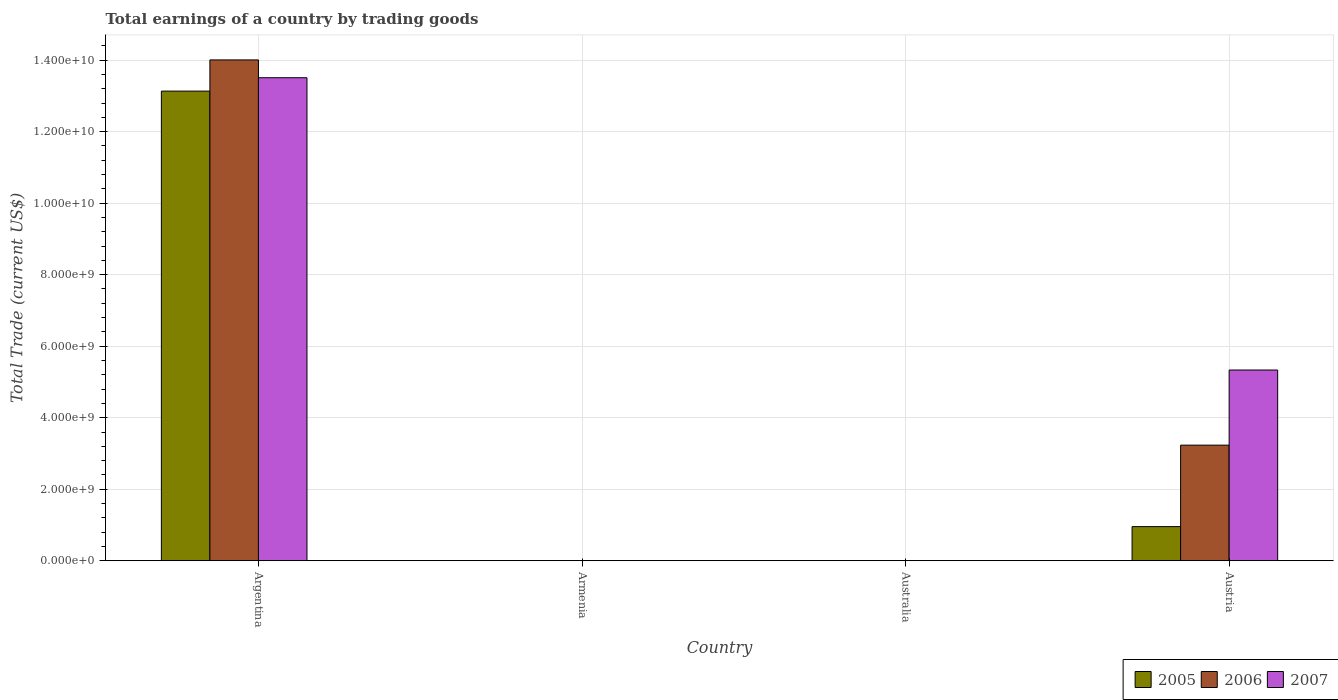How many different coloured bars are there?
Your answer should be compact. 3. Are the number of bars per tick equal to the number of legend labels?
Your answer should be compact. No. How many bars are there on the 2nd tick from the left?
Offer a very short reply. 0. How many bars are there on the 2nd tick from the right?
Your answer should be compact. 0. In how many cases, is the number of bars for a given country not equal to the number of legend labels?
Make the answer very short. 2. What is the total earnings in 2006 in Australia?
Your answer should be compact. 0. Across all countries, what is the maximum total earnings in 2006?
Your response must be concise. 1.40e+1. What is the total total earnings in 2006 in the graph?
Ensure brevity in your answer.  1.72e+1. What is the difference between the total earnings in 2005 in Argentina and that in Austria?
Make the answer very short. 1.22e+1. What is the average total earnings in 2005 per country?
Provide a succinct answer. 3.52e+09. What is the difference between the total earnings of/in 2007 and total earnings of/in 2005 in Argentina?
Offer a very short reply. 3.74e+08. What is the ratio of the total earnings in 2007 in Argentina to that in Austria?
Keep it short and to the point. 2.53. What is the difference between the highest and the lowest total earnings in 2006?
Give a very brief answer. 1.40e+1. In how many countries, is the total earnings in 2005 greater than the average total earnings in 2005 taken over all countries?
Ensure brevity in your answer.  1. How many bars are there?
Your response must be concise. 6. Are all the bars in the graph horizontal?
Your answer should be very brief. No. How many countries are there in the graph?
Offer a terse response. 4. Are the values on the major ticks of Y-axis written in scientific E-notation?
Your response must be concise. Yes. Does the graph contain any zero values?
Ensure brevity in your answer.  Yes. Does the graph contain grids?
Provide a succinct answer. Yes. Where does the legend appear in the graph?
Give a very brief answer. Bottom right. How many legend labels are there?
Ensure brevity in your answer.  3. How are the legend labels stacked?
Ensure brevity in your answer.  Horizontal. What is the title of the graph?
Ensure brevity in your answer.  Total earnings of a country by trading goods. What is the label or title of the X-axis?
Give a very brief answer. Country. What is the label or title of the Y-axis?
Ensure brevity in your answer.  Total Trade (current US$). What is the Total Trade (current US$) of 2005 in Argentina?
Ensure brevity in your answer.  1.31e+1. What is the Total Trade (current US$) of 2006 in Argentina?
Your answer should be compact. 1.40e+1. What is the Total Trade (current US$) in 2007 in Argentina?
Provide a short and direct response. 1.35e+1. What is the Total Trade (current US$) of 2007 in Armenia?
Your response must be concise. 0. What is the Total Trade (current US$) of 2006 in Australia?
Make the answer very short. 0. What is the Total Trade (current US$) of 2005 in Austria?
Provide a short and direct response. 9.55e+08. What is the Total Trade (current US$) in 2006 in Austria?
Offer a terse response. 3.23e+09. What is the Total Trade (current US$) in 2007 in Austria?
Provide a succinct answer. 5.33e+09. Across all countries, what is the maximum Total Trade (current US$) in 2005?
Ensure brevity in your answer.  1.31e+1. Across all countries, what is the maximum Total Trade (current US$) of 2006?
Offer a terse response. 1.40e+1. Across all countries, what is the maximum Total Trade (current US$) in 2007?
Keep it short and to the point. 1.35e+1. Across all countries, what is the minimum Total Trade (current US$) in 2006?
Your answer should be very brief. 0. Across all countries, what is the minimum Total Trade (current US$) in 2007?
Provide a short and direct response. 0. What is the total Total Trade (current US$) in 2005 in the graph?
Ensure brevity in your answer.  1.41e+1. What is the total Total Trade (current US$) in 2006 in the graph?
Give a very brief answer. 1.72e+1. What is the total Total Trade (current US$) in 2007 in the graph?
Provide a succinct answer. 1.88e+1. What is the difference between the Total Trade (current US$) of 2005 in Argentina and that in Austria?
Your answer should be very brief. 1.22e+1. What is the difference between the Total Trade (current US$) in 2006 in Argentina and that in Austria?
Provide a short and direct response. 1.08e+1. What is the difference between the Total Trade (current US$) in 2007 in Argentina and that in Austria?
Give a very brief answer. 8.17e+09. What is the difference between the Total Trade (current US$) in 2005 in Argentina and the Total Trade (current US$) in 2006 in Austria?
Provide a short and direct response. 9.90e+09. What is the difference between the Total Trade (current US$) of 2005 in Argentina and the Total Trade (current US$) of 2007 in Austria?
Give a very brief answer. 7.80e+09. What is the difference between the Total Trade (current US$) in 2006 in Argentina and the Total Trade (current US$) in 2007 in Austria?
Provide a short and direct response. 8.67e+09. What is the average Total Trade (current US$) of 2005 per country?
Offer a terse response. 3.52e+09. What is the average Total Trade (current US$) in 2006 per country?
Your answer should be compact. 4.31e+09. What is the average Total Trade (current US$) in 2007 per country?
Ensure brevity in your answer.  4.71e+09. What is the difference between the Total Trade (current US$) in 2005 and Total Trade (current US$) in 2006 in Argentina?
Offer a terse response. -8.72e+08. What is the difference between the Total Trade (current US$) of 2005 and Total Trade (current US$) of 2007 in Argentina?
Keep it short and to the point. -3.74e+08. What is the difference between the Total Trade (current US$) in 2006 and Total Trade (current US$) in 2007 in Argentina?
Provide a short and direct response. 4.98e+08. What is the difference between the Total Trade (current US$) of 2005 and Total Trade (current US$) of 2006 in Austria?
Provide a short and direct response. -2.28e+09. What is the difference between the Total Trade (current US$) in 2005 and Total Trade (current US$) in 2007 in Austria?
Make the answer very short. -4.38e+09. What is the difference between the Total Trade (current US$) of 2006 and Total Trade (current US$) of 2007 in Austria?
Your response must be concise. -2.10e+09. What is the ratio of the Total Trade (current US$) of 2005 in Argentina to that in Austria?
Your response must be concise. 13.75. What is the ratio of the Total Trade (current US$) of 2006 in Argentina to that in Austria?
Keep it short and to the point. 4.33. What is the ratio of the Total Trade (current US$) of 2007 in Argentina to that in Austria?
Offer a very short reply. 2.53. What is the difference between the highest and the lowest Total Trade (current US$) in 2005?
Keep it short and to the point. 1.31e+1. What is the difference between the highest and the lowest Total Trade (current US$) of 2006?
Your answer should be compact. 1.40e+1. What is the difference between the highest and the lowest Total Trade (current US$) in 2007?
Your response must be concise. 1.35e+1. 